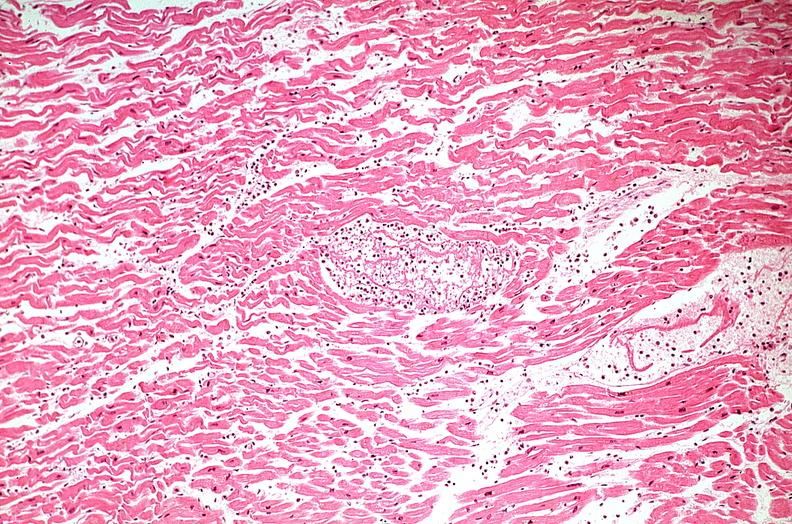s retroperitoneal liposarcoma present?
Answer the question using a single word or phrase. No 